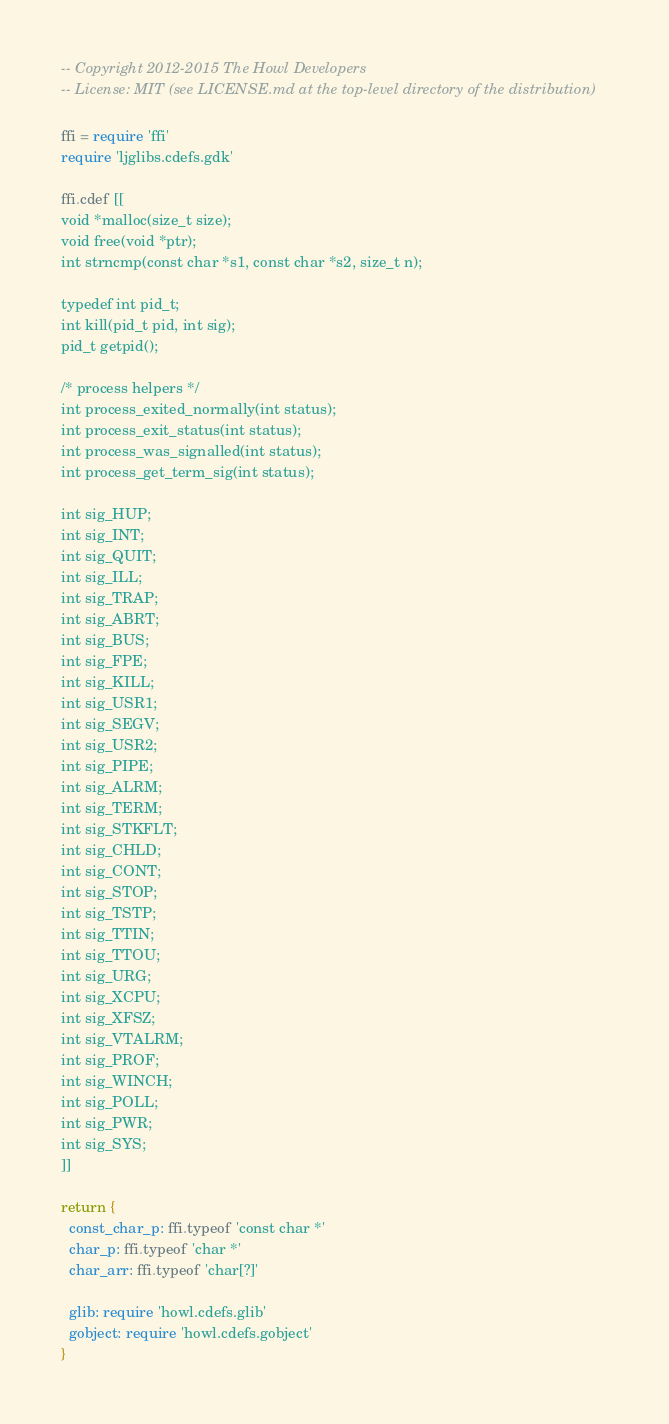Convert code to text. <code><loc_0><loc_0><loc_500><loc_500><_MoonScript_>-- Copyright 2012-2015 The Howl Developers
-- License: MIT (see LICENSE.md at the top-level directory of the distribution)

ffi = require 'ffi'
require 'ljglibs.cdefs.gdk'

ffi.cdef [[
void *malloc(size_t size);
void free(void *ptr);
int strncmp(const char *s1, const char *s2, size_t n);

typedef int pid_t;
int kill(pid_t pid, int sig);
pid_t getpid();

/* process helpers */
int process_exited_normally(int status);
int process_exit_status(int status);
int process_was_signalled(int status);
int process_get_term_sig(int status);

int sig_HUP;
int sig_INT;
int sig_QUIT;
int sig_ILL;
int sig_TRAP;
int sig_ABRT;
int sig_BUS;
int sig_FPE;
int sig_KILL;
int sig_USR1;
int sig_SEGV;
int sig_USR2;
int sig_PIPE;
int sig_ALRM;
int sig_TERM;
int sig_STKFLT;
int sig_CHLD;
int sig_CONT;
int sig_STOP;
int sig_TSTP;
int sig_TTIN;
int sig_TTOU;
int sig_URG;
int sig_XCPU;
int sig_XFSZ;
int sig_VTALRM;
int sig_PROF;
int sig_WINCH;
int sig_POLL;
int sig_PWR;
int sig_SYS;
]]

return {
  const_char_p: ffi.typeof 'const char *'
  char_p: ffi.typeof 'char *'
  char_arr: ffi.typeof 'char[?]'

  glib: require 'howl.cdefs.glib'
  gobject: require 'howl.cdefs.gobject'
}
</code> 